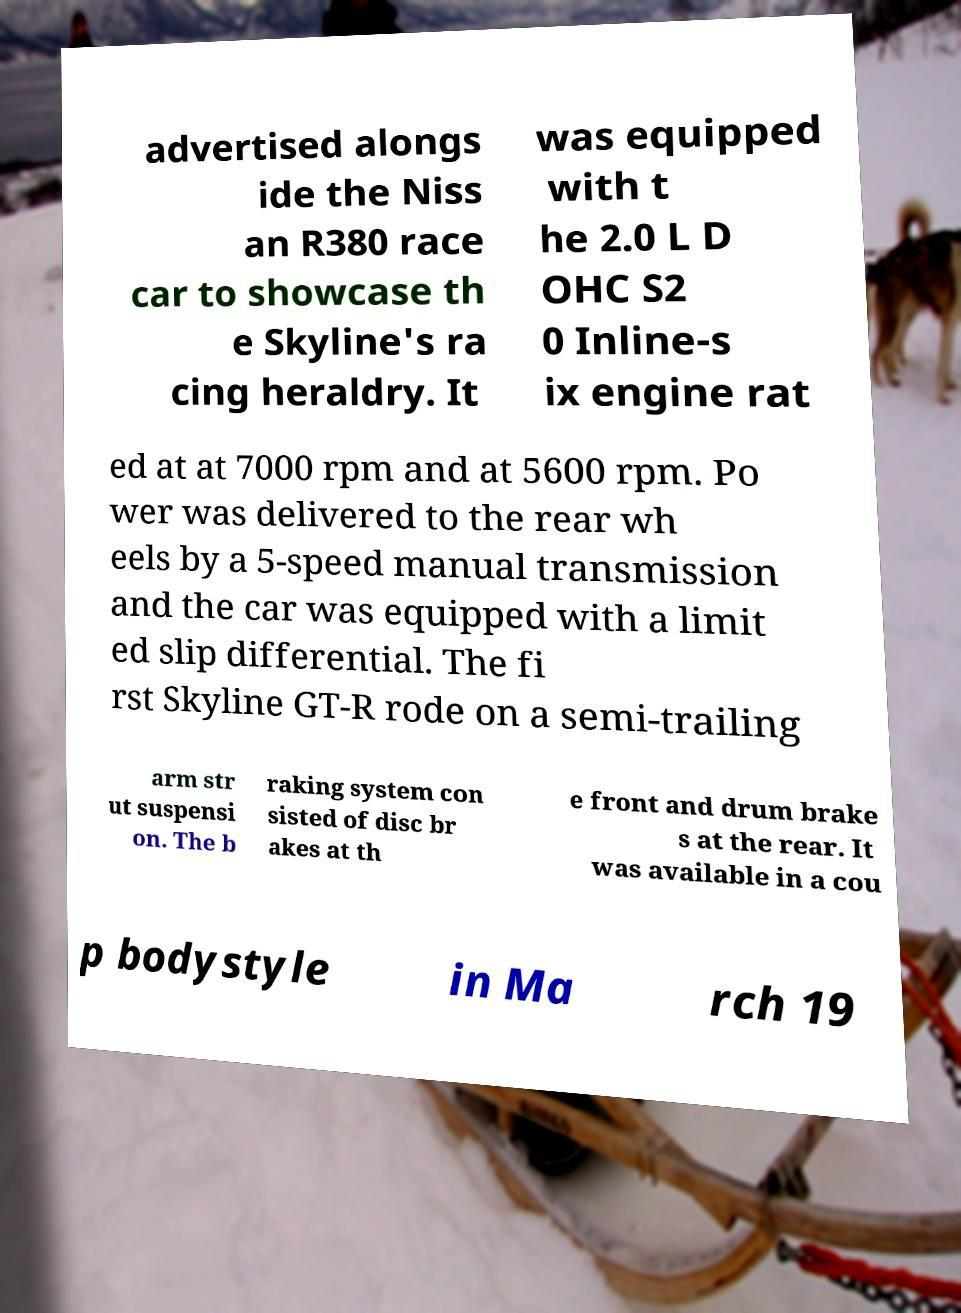Could you assist in decoding the text presented in this image and type it out clearly? advertised alongs ide the Niss an R380 race car to showcase th e Skyline's ra cing heraldry. It was equipped with t he 2.0 L D OHC S2 0 Inline-s ix engine rat ed at at 7000 rpm and at 5600 rpm. Po wer was delivered to the rear wh eels by a 5-speed manual transmission and the car was equipped with a limit ed slip differential. The fi rst Skyline GT-R rode on a semi-trailing arm str ut suspensi on. The b raking system con sisted of disc br akes at th e front and drum brake s at the rear. It was available in a cou p bodystyle in Ma rch 19 